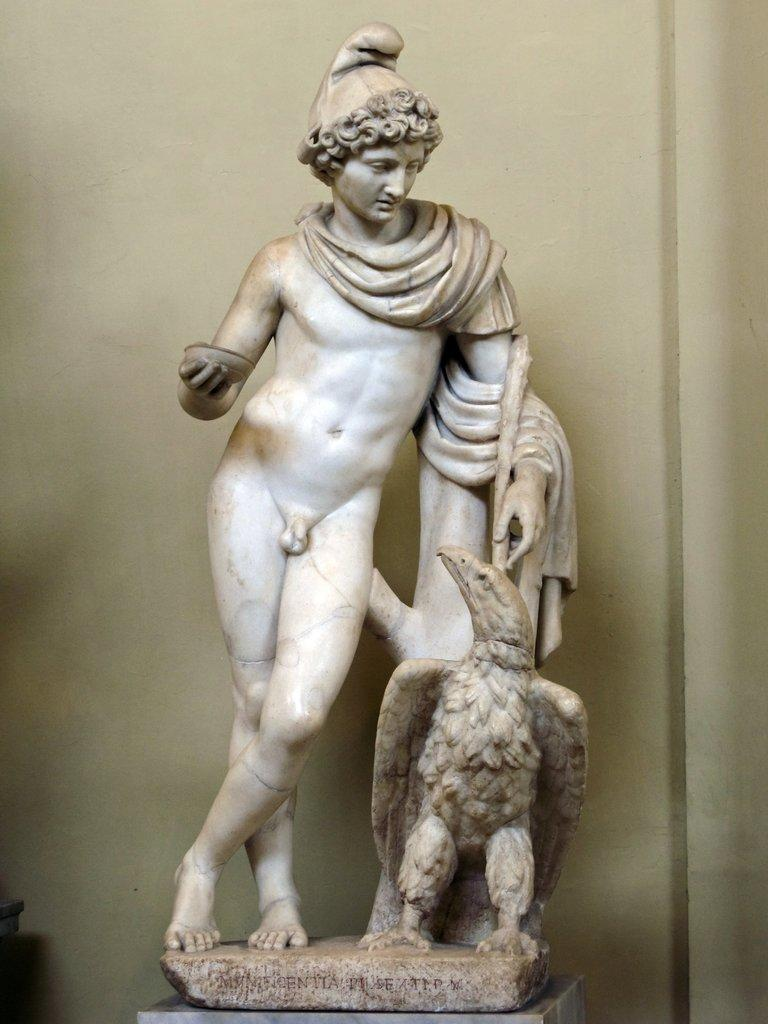What is the main subject in the center of the image? There is a statue in the center of the image. What can be seen in the background of the image? There is a wall visible in the background of the image. What is the price of the board in the image? There is no board present in the image, so it is not possible to determine its price. 